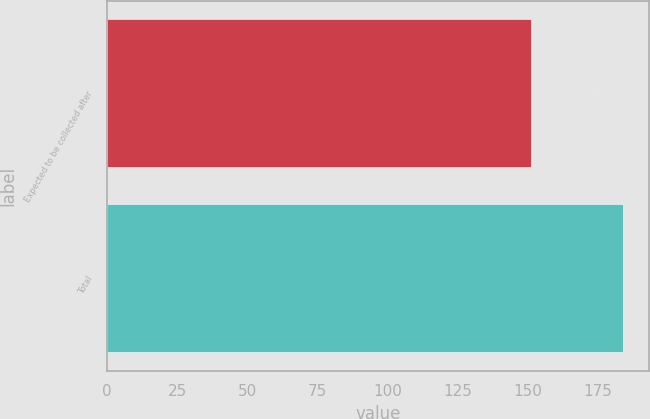<chart> <loc_0><loc_0><loc_500><loc_500><bar_chart><fcel>Expected to be collected after<fcel>Total<nl><fcel>151<fcel>184<nl></chart> 